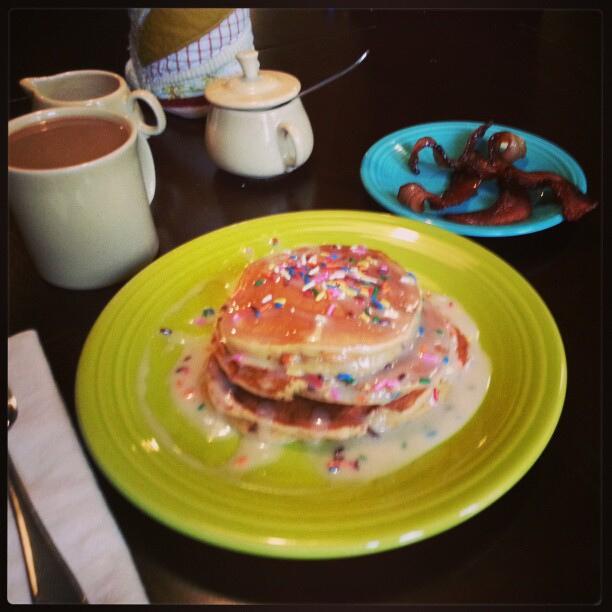Does this meal look healthy?
Quick response, please. No. Is there a white plate?
Keep it brief. No. What is in the mug?
Concise answer only. Coffee. What color is the plate?
Quick response, please. Yellow. Is the cup full of coffee?
Answer briefly. Yes. How many plates are on the table?
Quick response, please. 2. What is on the small blue plate?
Quick response, please. Bacon. How many candles are present?
Be succinct. 0. Are  the plates the same color?
Answer briefly. No. Is this Arabic food?
Give a very brief answer. No. Are there eggs on the plate?
Be succinct. No. 